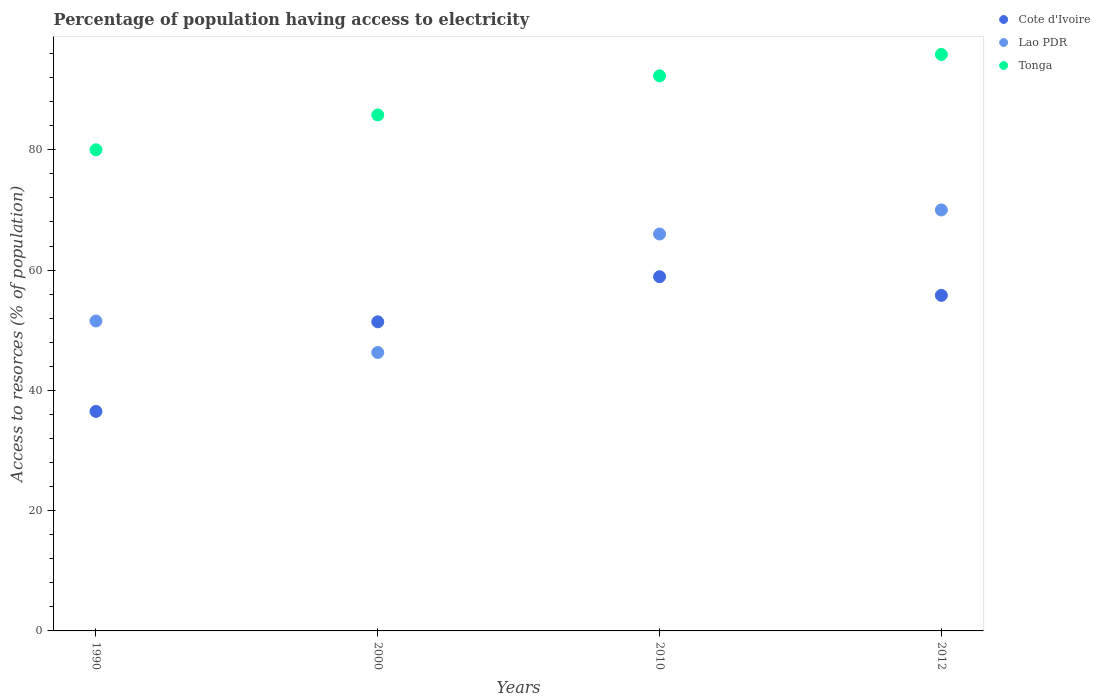How many different coloured dotlines are there?
Ensure brevity in your answer.  3. Is the number of dotlines equal to the number of legend labels?
Keep it short and to the point. Yes. What is the percentage of population having access to electricity in Cote d'Ivoire in 2000?
Provide a short and direct response. 51.4. Across all years, what is the maximum percentage of population having access to electricity in Cote d'Ivoire?
Your answer should be very brief. 58.9. Across all years, what is the minimum percentage of population having access to electricity in Tonga?
Your response must be concise. 80. In which year was the percentage of population having access to electricity in Lao PDR minimum?
Your answer should be very brief. 2000. What is the total percentage of population having access to electricity in Cote d'Ivoire in the graph?
Your answer should be very brief. 202.6. What is the difference between the percentage of population having access to electricity in Tonga in 2010 and that in 2012?
Make the answer very short. -3.56. What is the difference between the percentage of population having access to electricity in Cote d'Ivoire in 1990 and the percentage of population having access to electricity in Tonga in 2012?
Offer a very short reply. -59.36. What is the average percentage of population having access to electricity in Cote d'Ivoire per year?
Give a very brief answer. 50.65. In the year 1990, what is the difference between the percentage of population having access to electricity in Cote d'Ivoire and percentage of population having access to electricity in Lao PDR?
Provide a short and direct response. -15.04. In how many years, is the percentage of population having access to electricity in Cote d'Ivoire greater than 80 %?
Provide a succinct answer. 0. What is the ratio of the percentage of population having access to electricity in Lao PDR in 2000 to that in 2010?
Ensure brevity in your answer.  0.7. Is the percentage of population having access to electricity in Lao PDR in 1990 less than that in 2010?
Provide a short and direct response. Yes. What is the difference between the highest and the second highest percentage of population having access to electricity in Tonga?
Your answer should be very brief. 3.56. What is the difference between the highest and the lowest percentage of population having access to electricity in Tonga?
Give a very brief answer. 15.86. In how many years, is the percentage of population having access to electricity in Cote d'Ivoire greater than the average percentage of population having access to electricity in Cote d'Ivoire taken over all years?
Provide a succinct answer. 3. Is it the case that in every year, the sum of the percentage of population having access to electricity in Tonga and percentage of population having access to electricity in Cote d'Ivoire  is greater than the percentage of population having access to electricity in Lao PDR?
Your response must be concise. Yes. Is the percentage of population having access to electricity in Cote d'Ivoire strictly greater than the percentage of population having access to electricity in Tonga over the years?
Offer a terse response. No. Is the percentage of population having access to electricity in Cote d'Ivoire strictly less than the percentage of population having access to electricity in Tonga over the years?
Keep it short and to the point. Yes. How many dotlines are there?
Offer a very short reply. 3. How many years are there in the graph?
Provide a short and direct response. 4. What is the difference between two consecutive major ticks on the Y-axis?
Your answer should be compact. 20. Are the values on the major ticks of Y-axis written in scientific E-notation?
Keep it short and to the point. No. Does the graph contain any zero values?
Provide a succinct answer. No. Where does the legend appear in the graph?
Offer a terse response. Top right. How many legend labels are there?
Keep it short and to the point. 3. What is the title of the graph?
Give a very brief answer. Percentage of population having access to electricity. Does "Nepal" appear as one of the legend labels in the graph?
Make the answer very short. No. What is the label or title of the X-axis?
Your answer should be very brief. Years. What is the label or title of the Y-axis?
Ensure brevity in your answer.  Access to resorces (% of population). What is the Access to resorces (% of population) of Cote d'Ivoire in 1990?
Make the answer very short. 36.5. What is the Access to resorces (% of population) in Lao PDR in 1990?
Provide a succinct answer. 51.54. What is the Access to resorces (% of population) in Cote d'Ivoire in 2000?
Offer a very short reply. 51.4. What is the Access to resorces (% of population) in Lao PDR in 2000?
Your response must be concise. 46.3. What is the Access to resorces (% of population) in Tonga in 2000?
Your answer should be very brief. 85.8. What is the Access to resorces (% of population) in Cote d'Ivoire in 2010?
Provide a succinct answer. 58.9. What is the Access to resorces (% of population) in Tonga in 2010?
Offer a very short reply. 92.3. What is the Access to resorces (% of population) in Cote d'Ivoire in 2012?
Offer a very short reply. 55.8. What is the Access to resorces (% of population) of Tonga in 2012?
Give a very brief answer. 95.86. Across all years, what is the maximum Access to resorces (% of population) in Cote d'Ivoire?
Your answer should be compact. 58.9. Across all years, what is the maximum Access to resorces (% of population) of Tonga?
Your answer should be compact. 95.86. Across all years, what is the minimum Access to resorces (% of population) of Cote d'Ivoire?
Keep it short and to the point. 36.5. Across all years, what is the minimum Access to resorces (% of population) in Lao PDR?
Your answer should be very brief. 46.3. What is the total Access to resorces (% of population) in Cote d'Ivoire in the graph?
Make the answer very short. 202.6. What is the total Access to resorces (% of population) in Lao PDR in the graph?
Offer a terse response. 233.84. What is the total Access to resorces (% of population) in Tonga in the graph?
Provide a short and direct response. 353.96. What is the difference between the Access to resorces (% of population) in Cote d'Ivoire in 1990 and that in 2000?
Keep it short and to the point. -14.9. What is the difference between the Access to resorces (% of population) of Lao PDR in 1990 and that in 2000?
Make the answer very short. 5.24. What is the difference between the Access to resorces (% of population) in Tonga in 1990 and that in 2000?
Your response must be concise. -5.8. What is the difference between the Access to resorces (% of population) of Cote d'Ivoire in 1990 and that in 2010?
Keep it short and to the point. -22.4. What is the difference between the Access to resorces (% of population) of Lao PDR in 1990 and that in 2010?
Provide a short and direct response. -14.46. What is the difference between the Access to resorces (% of population) of Cote d'Ivoire in 1990 and that in 2012?
Offer a terse response. -19.3. What is the difference between the Access to resorces (% of population) in Lao PDR in 1990 and that in 2012?
Provide a short and direct response. -18.46. What is the difference between the Access to resorces (% of population) in Tonga in 1990 and that in 2012?
Provide a short and direct response. -15.86. What is the difference between the Access to resorces (% of population) of Cote d'Ivoire in 2000 and that in 2010?
Make the answer very short. -7.5. What is the difference between the Access to resorces (% of population) of Lao PDR in 2000 and that in 2010?
Provide a short and direct response. -19.7. What is the difference between the Access to resorces (% of population) in Tonga in 2000 and that in 2010?
Offer a terse response. -6.5. What is the difference between the Access to resorces (% of population) in Cote d'Ivoire in 2000 and that in 2012?
Provide a succinct answer. -4.4. What is the difference between the Access to resorces (% of population) in Lao PDR in 2000 and that in 2012?
Offer a very short reply. -23.7. What is the difference between the Access to resorces (% of population) in Tonga in 2000 and that in 2012?
Offer a very short reply. -10.06. What is the difference between the Access to resorces (% of population) in Cote d'Ivoire in 2010 and that in 2012?
Keep it short and to the point. 3.1. What is the difference between the Access to resorces (% of population) of Tonga in 2010 and that in 2012?
Keep it short and to the point. -3.56. What is the difference between the Access to resorces (% of population) of Cote d'Ivoire in 1990 and the Access to resorces (% of population) of Lao PDR in 2000?
Your answer should be compact. -9.8. What is the difference between the Access to resorces (% of population) of Cote d'Ivoire in 1990 and the Access to resorces (% of population) of Tonga in 2000?
Give a very brief answer. -49.3. What is the difference between the Access to resorces (% of population) in Lao PDR in 1990 and the Access to resorces (% of population) in Tonga in 2000?
Give a very brief answer. -34.26. What is the difference between the Access to resorces (% of population) of Cote d'Ivoire in 1990 and the Access to resorces (% of population) of Lao PDR in 2010?
Give a very brief answer. -29.5. What is the difference between the Access to resorces (% of population) in Cote d'Ivoire in 1990 and the Access to resorces (% of population) in Tonga in 2010?
Your response must be concise. -55.8. What is the difference between the Access to resorces (% of population) of Lao PDR in 1990 and the Access to resorces (% of population) of Tonga in 2010?
Give a very brief answer. -40.76. What is the difference between the Access to resorces (% of population) of Cote d'Ivoire in 1990 and the Access to resorces (% of population) of Lao PDR in 2012?
Your answer should be compact. -33.5. What is the difference between the Access to resorces (% of population) of Cote d'Ivoire in 1990 and the Access to resorces (% of population) of Tonga in 2012?
Offer a terse response. -59.36. What is the difference between the Access to resorces (% of population) in Lao PDR in 1990 and the Access to resorces (% of population) in Tonga in 2012?
Ensure brevity in your answer.  -44.32. What is the difference between the Access to resorces (% of population) in Cote d'Ivoire in 2000 and the Access to resorces (% of population) in Lao PDR in 2010?
Offer a terse response. -14.6. What is the difference between the Access to resorces (% of population) in Cote d'Ivoire in 2000 and the Access to resorces (% of population) in Tonga in 2010?
Provide a short and direct response. -40.9. What is the difference between the Access to resorces (% of population) in Lao PDR in 2000 and the Access to resorces (% of population) in Tonga in 2010?
Your response must be concise. -46. What is the difference between the Access to resorces (% of population) of Cote d'Ivoire in 2000 and the Access to resorces (% of population) of Lao PDR in 2012?
Keep it short and to the point. -18.6. What is the difference between the Access to resorces (% of population) in Cote d'Ivoire in 2000 and the Access to resorces (% of population) in Tonga in 2012?
Offer a terse response. -44.46. What is the difference between the Access to resorces (% of population) of Lao PDR in 2000 and the Access to resorces (% of population) of Tonga in 2012?
Your response must be concise. -49.56. What is the difference between the Access to resorces (% of population) of Cote d'Ivoire in 2010 and the Access to resorces (% of population) of Lao PDR in 2012?
Make the answer very short. -11.1. What is the difference between the Access to resorces (% of population) in Cote d'Ivoire in 2010 and the Access to resorces (% of population) in Tonga in 2012?
Keep it short and to the point. -36.96. What is the difference between the Access to resorces (% of population) of Lao PDR in 2010 and the Access to resorces (% of population) of Tonga in 2012?
Give a very brief answer. -29.86. What is the average Access to resorces (% of population) in Cote d'Ivoire per year?
Offer a very short reply. 50.65. What is the average Access to resorces (% of population) in Lao PDR per year?
Offer a very short reply. 58.46. What is the average Access to resorces (% of population) of Tonga per year?
Provide a short and direct response. 88.49. In the year 1990, what is the difference between the Access to resorces (% of population) in Cote d'Ivoire and Access to resorces (% of population) in Lao PDR?
Provide a short and direct response. -15.04. In the year 1990, what is the difference between the Access to resorces (% of population) in Cote d'Ivoire and Access to resorces (% of population) in Tonga?
Offer a very short reply. -43.5. In the year 1990, what is the difference between the Access to resorces (% of population) in Lao PDR and Access to resorces (% of population) in Tonga?
Ensure brevity in your answer.  -28.46. In the year 2000, what is the difference between the Access to resorces (% of population) of Cote d'Ivoire and Access to resorces (% of population) of Lao PDR?
Offer a very short reply. 5.1. In the year 2000, what is the difference between the Access to resorces (% of population) of Cote d'Ivoire and Access to resorces (% of population) of Tonga?
Provide a succinct answer. -34.4. In the year 2000, what is the difference between the Access to resorces (% of population) in Lao PDR and Access to resorces (% of population) in Tonga?
Give a very brief answer. -39.5. In the year 2010, what is the difference between the Access to resorces (% of population) of Cote d'Ivoire and Access to resorces (% of population) of Tonga?
Provide a succinct answer. -33.4. In the year 2010, what is the difference between the Access to resorces (% of population) in Lao PDR and Access to resorces (% of population) in Tonga?
Give a very brief answer. -26.3. In the year 2012, what is the difference between the Access to resorces (% of population) in Cote d'Ivoire and Access to resorces (% of population) in Tonga?
Your answer should be compact. -40.06. In the year 2012, what is the difference between the Access to resorces (% of population) in Lao PDR and Access to resorces (% of population) in Tonga?
Provide a succinct answer. -25.86. What is the ratio of the Access to resorces (% of population) in Cote d'Ivoire in 1990 to that in 2000?
Provide a short and direct response. 0.71. What is the ratio of the Access to resorces (% of population) of Lao PDR in 1990 to that in 2000?
Ensure brevity in your answer.  1.11. What is the ratio of the Access to resorces (% of population) of Tonga in 1990 to that in 2000?
Your answer should be compact. 0.93. What is the ratio of the Access to resorces (% of population) in Cote d'Ivoire in 1990 to that in 2010?
Provide a short and direct response. 0.62. What is the ratio of the Access to resorces (% of population) in Lao PDR in 1990 to that in 2010?
Provide a short and direct response. 0.78. What is the ratio of the Access to resorces (% of population) in Tonga in 1990 to that in 2010?
Your answer should be very brief. 0.87. What is the ratio of the Access to resorces (% of population) of Cote d'Ivoire in 1990 to that in 2012?
Provide a succinct answer. 0.65. What is the ratio of the Access to resorces (% of population) of Lao PDR in 1990 to that in 2012?
Offer a terse response. 0.74. What is the ratio of the Access to resorces (% of population) of Tonga in 1990 to that in 2012?
Provide a short and direct response. 0.83. What is the ratio of the Access to resorces (% of population) in Cote d'Ivoire in 2000 to that in 2010?
Provide a short and direct response. 0.87. What is the ratio of the Access to resorces (% of population) in Lao PDR in 2000 to that in 2010?
Your response must be concise. 0.7. What is the ratio of the Access to resorces (% of population) in Tonga in 2000 to that in 2010?
Provide a succinct answer. 0.93. What is the ratio of the Access to resorces (% of population) of Cote d'Ivoire in 2000 to that in 2012?
Provide a short and direct response. 0.92. What is the ratio of the Access to resorces (% of population) in Lao PDR in 2000 to that in 2012?
Your answer should be very brief. 0.66. What is the ratio of the Access to resorces (% of population) in Tonga in 2000 to that in 2012?
Provide a succinct answer. 0.9. What is the ratio of the Access to resorces (% of population) in Cote d'Ivoire in 2010 to that in 2012?
Provide a succinct answer. 1.06. What is the ratio of the Access to resorces (% of population) in Lao PDR in 2010 to that in 2012?
Offer a terse response. 0.94. What is the ratio of the Access to resorces (% of population) of Tonga in 2010 to that in 2012?
Make the answer very short. 0.96. What is the difference between the highest and the second highest Access to resorces (% of population) in Tonga?
Give a very brief answer. 3.56. What is the difference between the highest and the lowest Access to resorces (% of population) of Cote d'Ivoire?
Ensure brevity in your answer.  22.4. What is the difference between the highest and the lowest Access to resorces (% of population) in Lao PDR?
Your answer should be compact. 23.7. What is the difference between the highest and the lowest Access to resorces (% of population) of Tonga?
Make the answer very short. 15.86. 